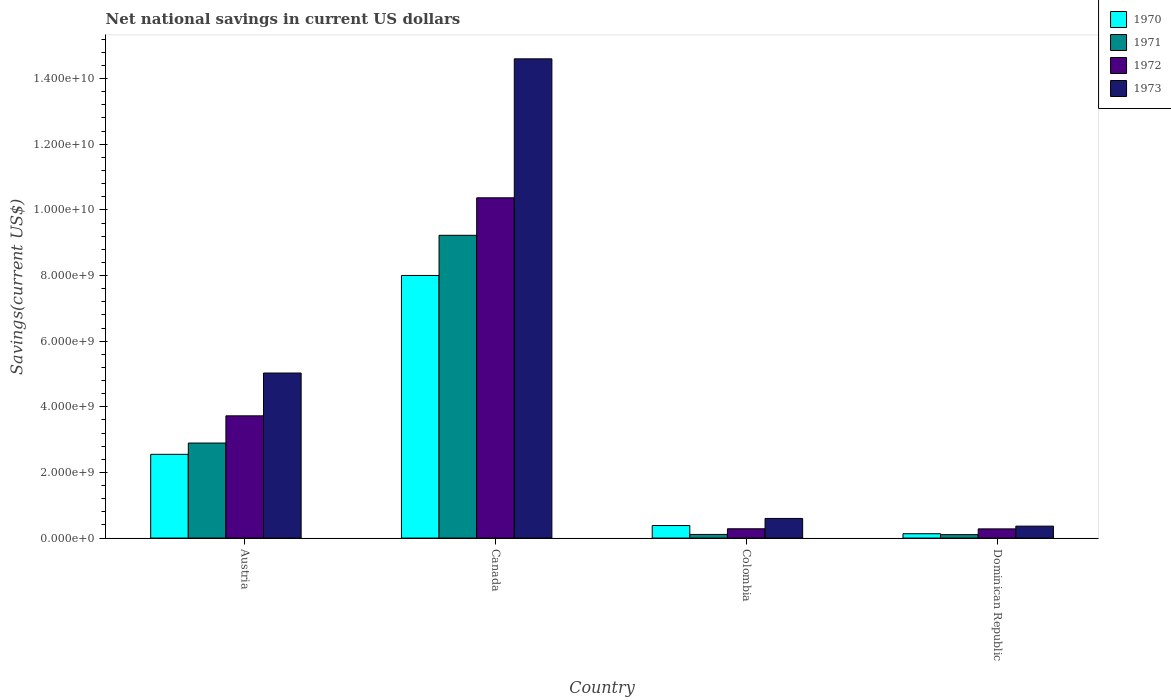How many groups of bars are there?
Provide a succinct answer. 4. How many bars are there on the 2nd tick from the left?
Ensure brevity in your answer.  4. What is the label of the 1st group of bars from the left?
Make the answer very short. Austria. In how many cases, is the number of bars for a given country not equal to the number of legend labels?
Offer a very short reply. 0. What is the net national savings in 1971 in Canada?
Offer a terse response. 9.23e+09. Across all countries, what is the maximum net national savings in 1971?
Give a very brief answer. 9.23e+09. Across all countries, what is the minimum net national savings in 1973?
Provide a short and direct response. 3.65e+08. In which country was the net national savings in 1973 minimum?
Offer a very short reply. Dominican Republic. What is the total net national savings in 1971 in the graph?
Your response must be concise. 1.23e+1. What is the difference between the net national savings in 1973 in Colombia and that in Dominican Republic?
Provide a short and direct response. 2.34e+08. What is the difference between the net national savings in 1973 in Austria and the net national savings in 1971 in Colombia?
Make the answer very short. 4.92e+09. What is the average net national savings in 1971 per country?
Offer a very short reply. 3.08e+09. What is the difference between the net national savings of/in 1971 and net national savings of/in 1970 in Canada?
Give a very brief answer. 1.22e+09. What is the ratio of the net national savings in 1972 in Austria to that in Canada?
Offer a very short reply. 0.36. Is the net national savings in 1971 in Colombia less than that in Dominican Republic?
Make the answer very short. No. What is the difference between the highest and the second highest net national savings in 1971?
Ensure brevity in your answer.  2.78e+09. What is the difference between the highest and the lowest net national savings in 1973?
Your answer should be compact. 1.42e+1. In how many countries, is the net national savings in 1970 greater than the average net national savings in 1970 taken over all countries?
Provide a short and direct response. 1. What does the 1st bar from the left in Austria represents?
Your response must be concise. 1970. What does the 2nd bar from the right in Dominican Republic represents?
Your response must be concise. 1972. Are all the bars in the graph horizontal?
Provide a succinct answer. No. How many countries are there in the graph?
Give a very brief answer. 4. What is the difference between two consecutive major ticks on the Y-axis?
Ensure brevity in your answer.  2.00e+09. Are the values on the major ticks of Y-axis written in scientific E-notation?
Offer a very short reply. Yes. Where does the legend appear in the graph?
Your answer should be very brief. Top right. How are the legend labels stacked?
Give a very brief answer. Vertical. What is the title of the graph?
Provide a short and direct response. Net national savings in current US dollars. What is the label or title of the Y-axis?
Keep it short and to the point. Savings(current US$). What is the Savings(current US$) of 1970 in Austria?
Your response must be concise. 2.55e+09. What is the Savings(current US$) in 1971 in Austria?
Offer a very short reply. 2.90e+09. What is the Savings(current US$) of 1972 in Austria?
Ensure brevity in your answer.  3.73e+09. What is the Savings(current US$) in 1973 in Austria?
Make the answer very short. 5.03e+09. What is the Savings(current US$) of 1970 in Canada?
Your answer should be very brief. 8.00e+09. What is the Savings(current US$) in 1971 in Canada?
Make the answer very short. 9.23e+09. What is the Savings(current US$) of 1972 in Canada?
Your answer should be very brief. 1.04e+1. What is the Savings(current US$) in 1973 in Canada?
Provide a succinct answer. 1.46e+1. What is the Savings(current US$) in 1970 in Colombia?
Provide a succinct answer. 3.83e+08. What is the Savings(current US$) in 1971 in Colombia?
Ensure brevity in your answer.  1.11e+08. What is the Savings(current US$) of 1972 in Colombia?
Ensure brevity in your answer.  2.84e+08. What is the Savings(current US$) in 1973 in Colombia?
Offer a terse response. 5.98e+08. What is the Savings(current US$) in 1970 in Dominican Republic?
Your answer should be compact. 1.33e+08. What is the Savings(current US$) in 1971 in Dominican Republic?
Provide a short and direct response. 1.05e+08. What is the Savings(current US$) in 1972 in Dominican Republic?
Ensure brevity in your answer.  2.80e+08. What is the Savings(current US$) in 1973 in Dominican Republic?
Ensure brevity in your answer.  3.65e+08. Across all countries, what is the maximum Savings(current US$) in 1970?
Make the answer very short. 8.00e+09. Across all countries, what is the maximum Savings(current US$) of 1971?
Your answer should be very brief. 9.23e+09. Across all countries, what is the maximum Savings(current US$) of 1972?
Offer a very short reply. 1.04e+1. Across all countries, what is the maximum Savings(current US$) in 1973?
Offer a very short reply. 1.46e+1. Across all countries, what is the minimum Savings(current US$) in 1970?
Give a very brief answer. 1.33e+08. Across all countries, what is the minimum Savings(current US$) in 1971?
Make the answer very short. 1.05e+08. Across all countries, what is the minimum Savings(current US$) in 1972?
Offer a terse response. 2.80e+08. Across all countries, what is the minimum Savings(current US$) in 1973?
Offer a terse response. 3.65e+08. What is the total Savings(current US$) in 1970 in the graph?
Your response must be concise. 1.11e+1. What is the total Savings(current US$) of 1971 in the graph?
Offer a very short reply. 1.23e+1. What is the total Savings(current US$) in 1972 in the graph?
Your answer should be compact. 1.47e+1. What is the total Savings(current US$) in 1973 in the graph?
Keep it short and to the point. 2.06e+1. What is the difference between the Savings(current US$) of 1970 in Austria and that in Canada?
Your response must be concise. -5.45e+09. What is the difference between the Savings(current US$) in 1971 in Austria and that in Canada?
Offer a terse response. -6.33e+09. What is the difference between the Savings(current US$) of 1972 in Austria and that in Canada?
Your response must be concise. -6.64e+09. What is the difference between the Savings(current US$) of 1973 in Austria and that in Canada?
Provide a short and direct response. -9.57e+09. What is the difference between the Savings(current US$) of 1970 in Austria and that in Colombia?
Offer a very short reply. 2.17e+09. What is the difference between the Savings(current US$) in 1971 in Austria and that in Colombia?
Make the answer very short. 2.78e+09. What is the difference between the Savings(current US$) of 1972 in Austria and that in Colombia?
Offer a terse response. 3.44e+09. What is the difference between the Savings(current US$) of 1973 in Austria and that in Colombia?
Your response must be concise. 4.43e+09. What is the difference between the Savings(current US$) in 1970 in Austria and that in Dominican Republic?
Your response must be concise. 2.42e+09. What is the difference between the Savings(current US$) in 1971 in Austria and that in Dominican Republic?
Your response must be concise. 2.79e+09. What is the difference between the Savings(current US$) in 1972 in Austria and that in Dominican Republic?
Provide a short and direct response. 3.44e+09. What is the difference between the Savings(current US$) of 1973 in Austria and that in Dominican Republic?
Give a very brief answer. 4.66e+09. What is the difference between the Savings(current US$) in 1970 in Canada and that in Colombia?
Provide a succinct answer. 7.62e+09. What is the difference between the Savings(current US$) in 1971 in Canada and that in Colombia?
Give a very brief answer. 9.11e+09. What is the difference between the Savings(current US$) in 1972 in Canada and that in Colombia?
Make the answer very short. 1.01e+1. What is the difference between the Savings(current US$) of 1973 in Canada and that in Colombia?
Make the answer very short. 1.40e+1. What is the difference between the Savings(current US$) of 1970 in Canada and that in Dominican Republic?
Your answer should be compact. 7.87e+09. What is the difference between the Savings(current US$) in 1971 in Canada and that in Dominican Republic?
Provide a succinct answer. 9.12e+09. What is the difference between the Savings(current US$) in 1972 in Canada and that in Dominican Republic?
Provide a short and direct response. 1.01e+1. What is the difference between the Savings(current US$) in 1973 in Canada and that in Dominican Republic?
Provide a succinct answer. 1.42e+1. What is the difference between the Savings(current US$) of 1970 in Colombia and that in Dominican Republic?
Ensure brevity in your answer.  2.50e+08. What is the difference between the Savings(current US$) of 1971 in Colombia and that in Dominican Republic?
Your answer should be very brief. 6.03e+06. What is the difference between the Savings(current US$) of 1972 in Colombia and that in Dominican Republic?
Provide a succinct answer. 3.48e+06. What is the difference between the Savings(current US$) in 1973 in Colombia and that in Dominican Republic?
Your answer should be compact. 2.34e+08. What is the difference between the Savings(current US$) of 1970 in Austria and the Savings(current US$) of 1971 in Canada?
Provide a succinct answer. -6.67e+09. What is the difference between the Savings(current US$) of 1970 in Austria and the Savings(current US$) of 1972 in Canada?
Ensure brevity in your answer.  -7.82e+09. What is the difference between the Savings(current US$) of 1970 in Austria and the Savings(current US$) of 1973 in Canada?
Give a very brief answer. -1.20e+1. What is the difference between the Savings(current US$) of 1971 in Austria and the Savings(current US$) of 1972 in Canada?
Your answer should be compact. -7.47e+09. What is the difference between the Savings(current US$) of 1971 in Austria and the Savings(current US$) of 1973 in Canada?
Offer a very short reply. -1.17e+1. What is the difference between the Savings(current US$) in 1972 in Austria and the Savings(current US$) in 1973 in Canada?
Keep it short and to the point. -1.09e+1. What is the difference between the Savings(current US$) of 1970 in Austria and the Savings(current US$) of 1971 in Colombia?
Offer a terse response. 2.44e+09. What is the difference between the Savings(current US$) in 1970 in Austria and the Savings(current US$) in 1972 in Colombia?
Your response must be concise. 2.27e+09. What is the difference between the Savings(current US$) of 1970 in Austria and the Savings(current US$) of 1973 in Colombia?
Give a very brief answer. 1.95e+09. What is the difference between the Savings(current US$) of 1971 in Austria and the Savings(current US$) of 1972 in Colombia?
Offer a very short reply. 2.61e+09. What is the difference between the Savings(current US$) in 1971 in Austria and the Savings(current US$) in 1973 in Colombia?
Make the answer very short. 2.30e+09. What is the difference between the Savings(current US$) of 1972 in Austria and the Savings(current US$) of 1973 in Colombia?
Your response must be concise. 3.13e+09. What is the difference between the Savings(current US$) of 1970 in Austria and the Savings(current US$) of 1971 in Dominican Republic?
Offer a very short reply. 2.45e+09. What is the difference between the Savings(current US$) of 1970 in Austria and the Savings(current US$) of 1972 in Dominican Republic?
Give a very brief answer. 2.27e+09. What is the difference between the Savings(current US$) in 1970 in Austria and the Savings(current US$) in 1973 in Dominican Republic?
Offer a very short reply. 2.19e+09. What is the difference between the Savings(current US$) in 1971 in Austria and the Savings(current US$) in 1972 in Dominican Republic?
Make the answer very short. 2.62e+09. What is the difference between the Savings(current US$) in 1971 in Austria and the Savings(current US$) in 1973 in Dominican Republic?
Provide a succinct answer. 2.53e+09. What is the difference between the Savings(current US$) in 1972 in Austria and the Savings(current US$) in 1973 in Dominican Republic?
Make the answer very short. 3.36e+09. What is the difference between the Savings(current US$) in 1970 in Canada and the Savings(current US$) in 1971 in Colombia?
Provide a short and direct response. 7.89e+09. What is the difference between the Savings(current US$) in 1970 in Canada and the Savings(current US$) in 1972 in Colombia?
Keep it short and to the point. 7.72e+09. What is the difference between the Savings(current US$) of 1970 in Canada and the Savings(current US$) of 1973 in Colombia?
Ensure brevity in your answer.  7.40e+09. What is the difference between the Savings(current US$) in 1971 in Canada and the Savings(current US$) in 1972 in Colombia?
Your answer should be compact. 8.94e+09. What is the difference between the Savings(current US$) in 1971 in Canada and the Savings(current US$) in 1973 in Colombia?
Your response must be concise. 8.63e+09. What is the difference between the Savings(current US$) of 1972 in Canada and the Savings(current US$) of 1973 in Colombia?
Offer a very short reply. 9.77e+09. What is the difference between the Savings(current US$) of 1970 in Canada and the Savings(current US$) of 1971 in Dominican Republic?
Make the answer very short. 7.90e+09. What is the difference between the Savings(current US$) of 1970 in Canada and the Savings(current US$) of 1972 in Dominican Republic?
Your answer should be compact. 7.72e+09. What is the difference between the Savings(current US$) in 1970 in Canada and the Savings(current US$) in 1973 in Dominican Republic?
Keep it short and to the point. 7.64e+09. What is the difference between the Savings(current US$) of 1971 in Canada and the Savings(current US$) of 1972 in Dominican Republic?
Your answer should be very brief. 8.94e+09. What is the difference between the Savings(current US$) in 1971 in Canada and the Savings(current US$) in 1973 in Dominican Republic?
Provide a short and direct response. 8.86e+09. What is the difference between the Savings(current US$) of 1972 in Canada and the Savings(current US$) of 1973 in Dominican Republic?
Your response must be concise. 1.00e+1. What is the difference between the Savings(current US$) of 1970 in Colombia and the Savings(current US$) of 1971 in Dominican Republic?
Keep it short and to the point. 2.77e+08. What is the difference between the Savings(current US$) of 1970 in Colombia and the Savings(current US$) of 1972 in Dominican Republic?
Offer a terse response. 1.02e+08. What is the difference between the Savings(current US$) of 1970 in Colombia and the Savings(current US$) of 1973 in Dominican Republic?
Offer a very short reply. 1.82e+07. What is the difference between the Savings(current US$) in 1971 in Colombia and the Savings(current US$) in 1972 in Dominican Republic?
Keep it short and to the point. -1.69e+08. What is the difference between the Savings(current US$) in 1971 in Colombia and the Savings(current US$) in 1973 in Dominican Republic?
Your response must be concise. -2.53e+08. What is the difference between the Savings(current US$) of 1972 in Colombia and the Savings(current US$) of 1973 in Dominican Republic?
Give a very brief answer. -8.05e+07. What is the average Savings(current US$) of 1970 per country?
Your answer should be very brief. 2.77e+09. What is the average Savings(current US$) of 1971 per country?
Your response must be concise. 3.08e+09. What is the average Savings(current US$) of 1972 per country?
Offer a terse response. 3.66e+09. What is the average Savings(current US$) of 1973 per country?
Give a very brief answer. 5.15e+09. What is the difference between the Savings(current US$) in 1970 and Savings(current US$) in 1971 in Austria?
Offer a very short reply. -3.44e+08. What is the difference between the Savings(current US$) of 1970 and Savings(current US$) of 1972 in Austria?
Offer a terse response. -1.17e+09. What is the difference between the Savings(current US$) of 1970 and Savings(current US$) of 1973 in Austria?
Provide a short and direct response. -2.48e+09. What is the difference between the Savings(current US$) in 1971 and Savings(current US$) in 1972 in Austria?
Give a very brief answer. -8.29e+08. What is the difference between the Savings(current US$) in 1971 and Savings(current US$) in 1973 in Austria?
Offer a very short reply. -2.13e+09. What is the difference between the Savings(current US$) of 1972 and Savings(current US$) of 1973 in Austria?
Offer a terse response. -1.30e+09. What is the difference between the Savings(current US$) of 1970 and Savings(current US$) of 1971 in Canada?
Give a very brief answer. -1.22e+09. What is the difference between the Savings(current US$) in 1970 and Savings(current US$) in 1972 in Canada?
Ensure brevity in your answer.  -2.37e+09. What is the difference between the Savings(current US$) of 1970 and Savings(current US$) of 1973 in Canada?
Ensure brevity in your answer.  -6.60e+09. What is the difference between the Savings(current US$) of 1971 and Savings(current US$) of 1972 in Canada?
Your answer should be very brief. -1.14e+09. What is the difference between the Savings(current US$) of 1971 and Savings(current US$) of 1973 in Canada?
Provide a succinct answer. -5.38e+09. What is the difference between the Savings(current US$) of 1972 and Savings(current US$) of 1973 in Canada?
Make the answer very short. -4.23e+09. What is the difference between the Savings(current US$) in 1970 and Savings(current US$) in 1971 in Colombia?
Give a very brief answer. 2.71e+08. What is the difference between the Savings(current US$) of 1970 and Savings(current US$) of 1972 in Colombia?
Offer a very short reply. 9.87e+07. What is the difference between the Savings(current US$) in 1970 and Savings(current US$) in 1973 in Colombia?
Your response must be concise. -2.16e+08. What is the difference between the Savings(current US$) of 1971 and Savings(current US$) of 1972 in Colombia?
Ensure brevity in your answer.  -1.73e+08. What is the difference between the Savings(current US$) in 1971 and Savings(current US$) in 1973 in Colombia?
Offer a very short reply. -4.87e+08. What is the difference between the Savings(current US$) in 1972 and Savings(current US$) in 1973 in Colombia?
Offer a terse response. -3.14e+08. What is the difference between the Savings(current US$) of 1970 and Savings(current US$) of 1971 in Dominican Republic?
Provide a succinct answer. 2.74e+07. What is the difference between the Savings(current US$) of 1970 and Savings(current US$) of 1972 in Dominican Republic?
Give a very brief answer. -1.48e+08. What is the difference between the Savings(current US$) in 1970 and Savings(current US$) in 1973 in Dominican Republic?
Your answer should be very brief. -2.32e+08. What is the difference between the Savings(current US$) in 1971 and Savings(current US$) in 1972 in Dominican Republic?
Offer a terse response. -1.75e+08. What is the difference between the Savings(current US$) of 1971 and Savings(current US$) of 1973 in Dominican Republic?
Ensure brevity in your answer.  -2.59e+08. What is the difference between the Savings(current US$) in 1972 and Savings(current US$) in 1973 in Dominican Republic?
Offer a terse response. -8.40e+07. What is the ratio of the Savings(current US$) in 1970 in Austria to that in Canada?
Ensure brevity in your answer.  0.32. What is the ratio of the Savings(current US$) of 1971 in Austria to that in Canada?
Ensure brevity in your answer.  0.31. What is the ratio of the Savings(current US$) of 1972 in Austria to that in Canada?
Ensure brevity in your answer.  0.36. What is the ratio of the Savings(current US$) in 1973 in Austria to that in Canada?
Offer a very short reply. 0.34. What is the ratio of the Savings(current US$) in 1970 in Austria to that in Colombia?
Your answer should be compact. 6.67. What is the ratio of the Savings(current US$) of 1971 in Austria to that in Colombia?
Your response must be concise. 25.99. What is the ratio of the Savings(current US$) of 1972 in Austria to that in Colombia?
Your answer should be compact. 13.12. What is the ratio of the Savings(current US$) in 1973 in Austria to that in Colombia?
Ensure brevity in your answer.  8.4. What is the ratio of the Savings(current US$) in 1970 in Austria to that in Dominican Republic?
Ensure brevity in your answer.  19.23. What is the ratio of the Savings(current US$) of 1971 in Austria to that in Dominican Republic?
Offer a very short reply. 27.48. What is the ratio of the Savings(current US$) of 1972 in Austria to that in Dominican Republic?
Ensure brevity in your answer.  13.28. What is the ratio of the Savings(current US$) of 1973 in Austria to that in Dominican Republic?
Your answer should be compact. 13.8. What is the ratio of the Savings(current US$) in 1970 in Canada to that in Colombia?
Give a very brief answer. 20.91. What is the ratio of the Savings(current US$) in 1971 in Canada to that in Colombia?
Offer a terse response. 82.79. What is the ratio of the Savings(current US$) of 1972 in Canada to that in Colombia?
Give a very brief answer. 36.51. What is the ratio of the Savings(current US$) of 1973 in Canada to that in Colombia?
Offer a very short reply. 24.4. What is the ratio of the Savings(current US$) in 1970 in Canada to that in Dominican Republic?
Ensure brevity in your answer.  60.27. What is the ratio of the Savings(current US$) of 1971 in Canada to that in Dominican Republic?
Your answer should be very brief. 87.52. What is the ratio of the Savings(current US$) of 1972 in Canada to that in Dominican Republic?
Provide a succinct answer. 36.96. What is the ratio of the Savings(current US$) of 1973 in Canada to that in Dominican Republic?
Your answer should be very brief. 40.06. What is the ratio of the Savings(current US$) in 1970 in Colombia to that in Dominican Republic?
Provide a short and direct response. 2.88. What is the ratio of the Savings(current US$) in 1971 in Colombia to that in Dominican Republic?
Give a very brief answer. 1.06. What is the ratio of the Savings(current US$) of 1972 in Colombia to that in Dominican Republic?
Give a very brief answer. 1.01. What is the ratio of the Savings(current US$) in 1973 in Colombia to that in Dominican Republic?
Your answer should be compact. 1.64. What is the difference between the highest and the second highest Savings(current US$) in 1970?
Give a very brief answer. 5.45e+09. What is the difference between the highest and the second highest Savings(current US$) of 1971?
Give a very brief answer. 6.33e+09. What is the difference between the highest and the second highest Savings(current US$) of 1972?
Make the answer very short. 6.64e+09. What is the difference between the highest and the second highest Savings(current US$) of 1973?
Offer a terse response. 9.57e+09. What is the difference between the highest and the lowest Savings(current US$) in 1970?
Provide a short and direct response. 7.87e+09. What is the difference between the highest and the lowest Savings(current US$) of 1971?
Your response must be concise. 9.12e+09. What is the difference between the highest and the lowest Savings(current US$) in 1972?
Offer a terse response. 1.01e+1. What is the difference between the highest and the lowest Savings(current US$) of 1973?
Give a very brief answer. 1.42e+1. 